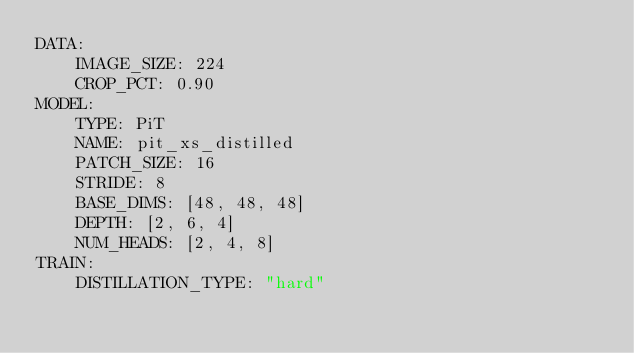Convert code to text. <code><loc_0><loc_0><loc_500><loc_500><_YAML_>DATA:
    IMAGE_SIZE: 224
    CROP_PCT: 0.90
MODEL:
    TYPE: PiT
    NAME: pit_xs_distilled
    PATCH_SIZE: 16
    STRIDE: 8
    BASE_DIMS: [48, 48, 48]
    DEPTH: [2, 6, 4]
    NUM_HEADS: [2, 4, 8]
TRAIN:
    DISTILLATION_TYPE: "hard"
</code> 